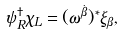<formula> <loc_0><loc_0><loc_500><loc_500>\psi _ { R } ^ { \dagger } \chi _ { L } = ( \omega ^ { \dot { \beta } } ) ^ { \ast } \xi _ { \beta } ,</formula> 